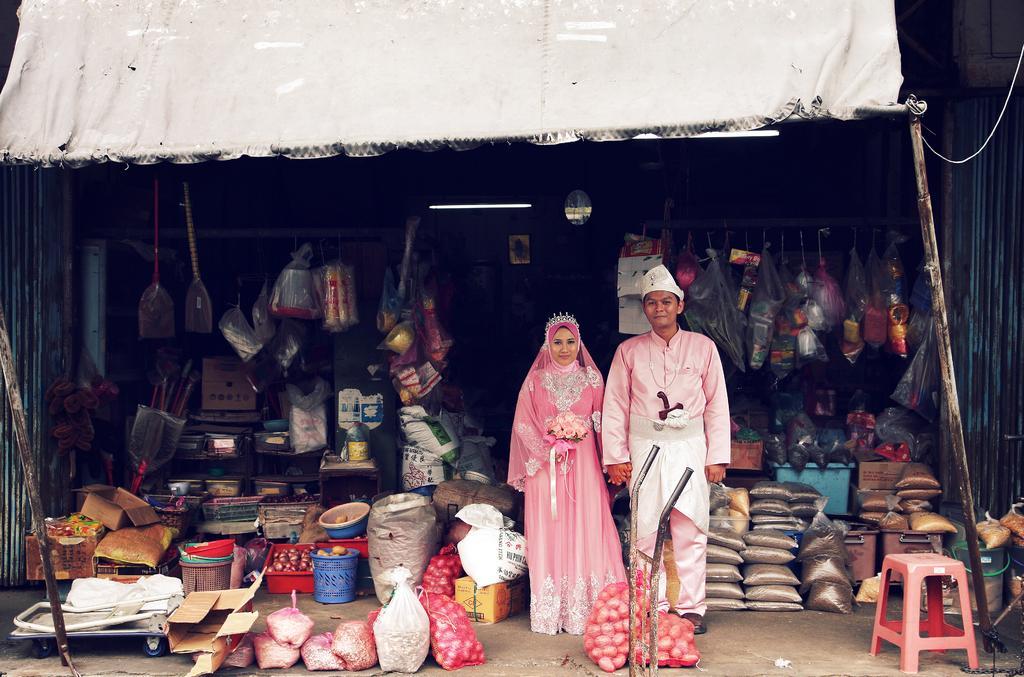Please provide a concise description of this image. In this image, we can see a woman and man are standing and they are smiling. At the bottom, we can see few bags, stool, wheels, carton box. Background there are so many things we can see. On the right side, there is a pole. Top of the image, there is a cloth and rope we can see. 